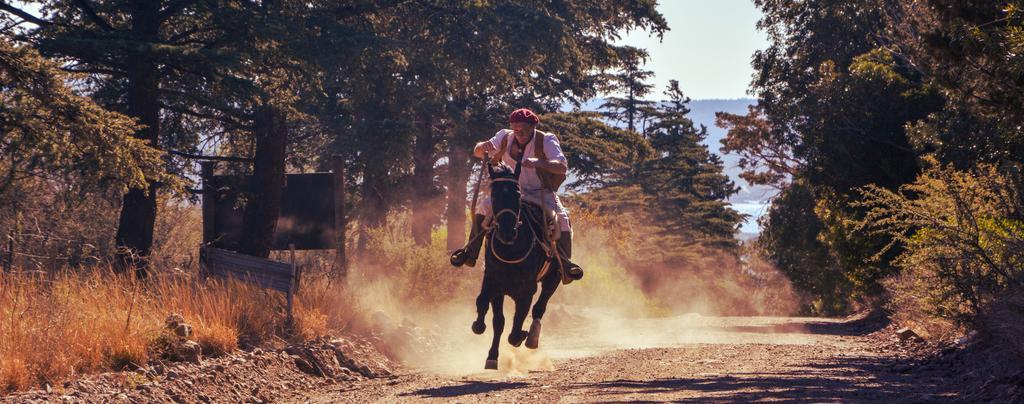In one or two sentences, can you explain what this image depicts? In the middle of the image, there is a person in white color dress, riding a horse on the road. Beside this house, there is dust. On both sides of this road, there are trees and plants. In the background, there is a mountain and there is sky. 